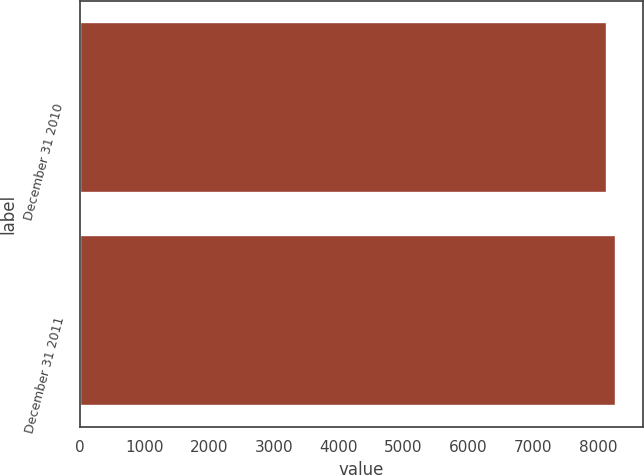<chart> <loc_0><loc_0><loc_500><loc_500><bar_chart><fcel>December 31 2010<fcel>December 31 2011<nl><fcel>8149<fcel>8285<nl></chart> 